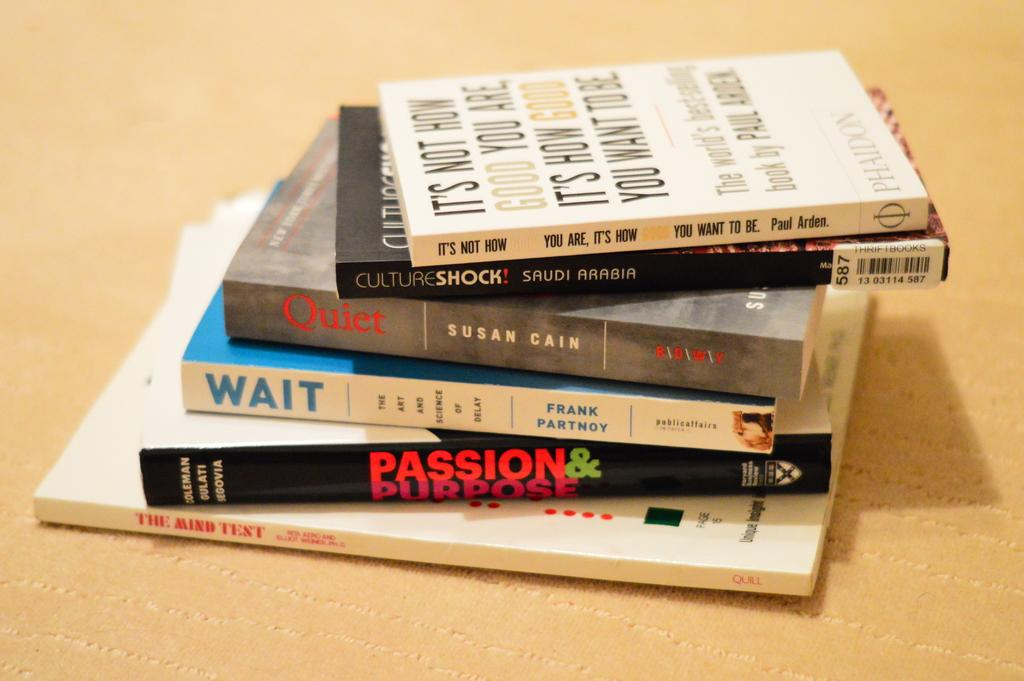Provide a one-sentence caption for the provided image. stacks of books like Passion Purpose and Quiet. 